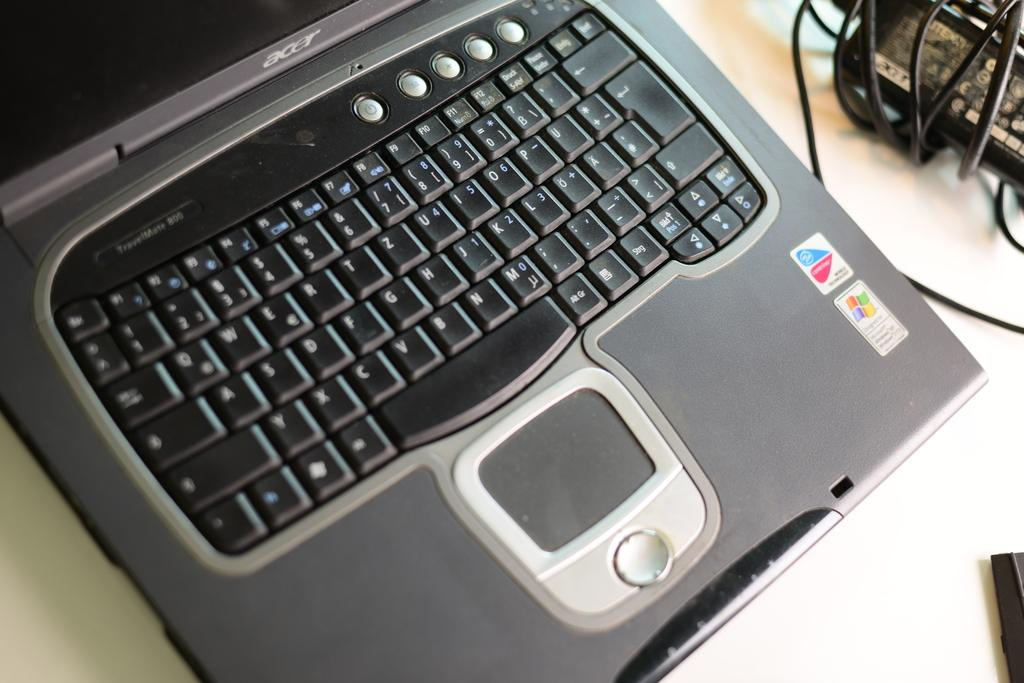<image>
Present a compact description of the photo's key features. An open Acer laptop with the keyboard visible. 